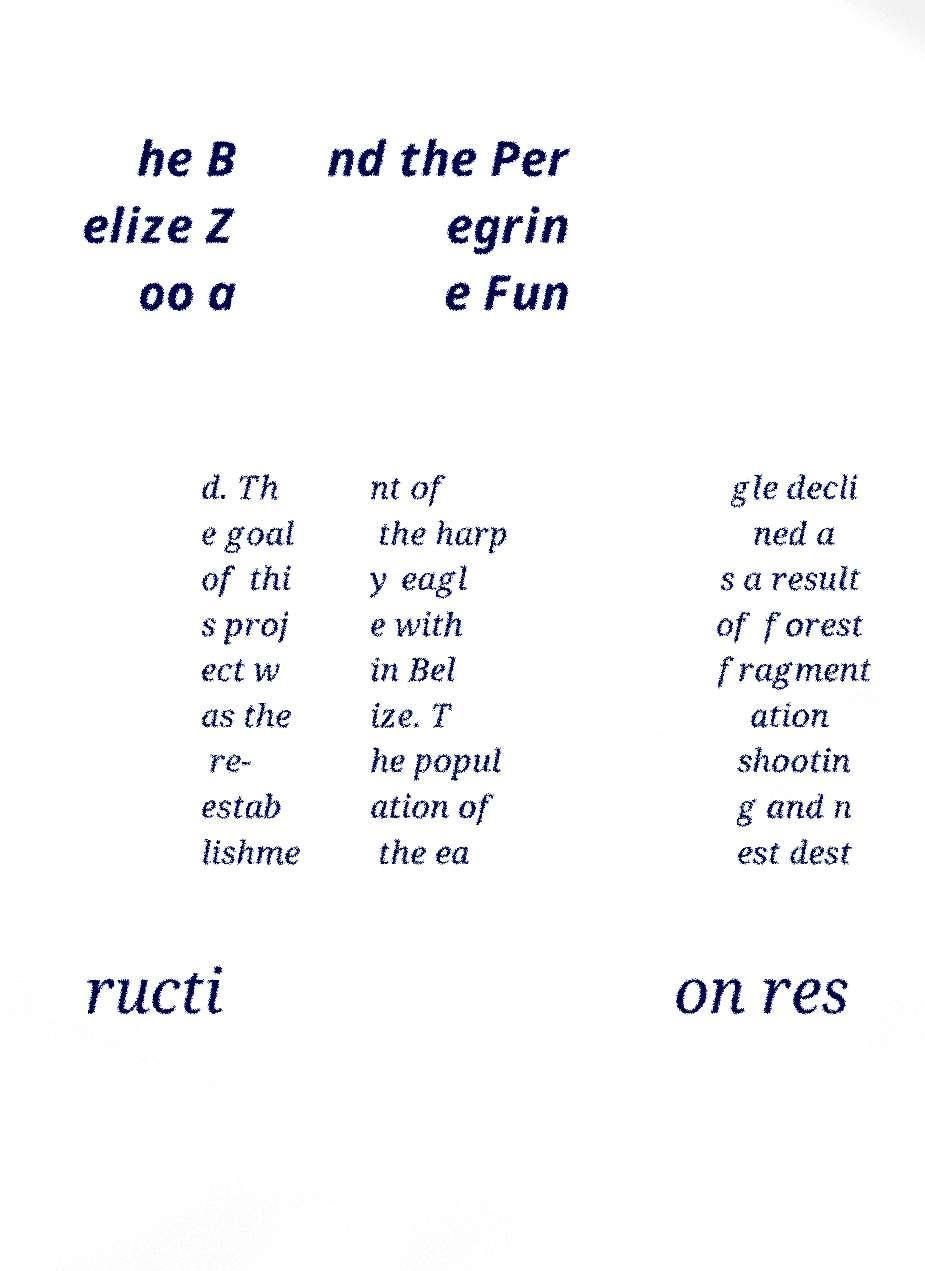I need the written content from this picture converted into text. Can you do that? he B elize Z oo a nd the Per egrin e Fun d. Th e goal of thi s proj ect w as the re- estab lishme nt of the harp y eagl e with in Bel ize. T he popul ation of the ea gle decli ned a s a result of forest fragment ation shootin g and n est dest ructi on res 